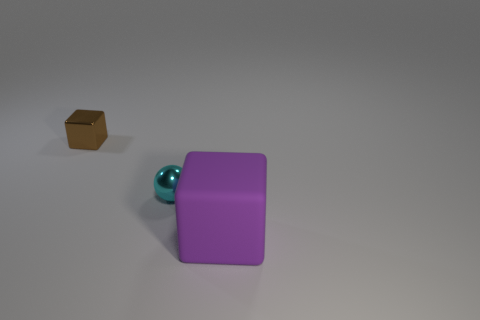Is the large matte thing the same color as the small metal ball?
Offer a terse response. No. There is a thing that is in front of the brown metallic thing and behind the large purple object; what is its size?
Your answer should be very brief. Small. Is there any other thing that has the same material as the purple block?
Give a very brief answer. No. Are the purple thing and the block that is behind the small cyan ball made of the same material?
Your response must be concise. No. Are there fewer big purple cubes that are in front of the big purple cube than cyan shiny things right of the tiny metal sphere?
Provide a succinct answer. No. What material is the tiny object behind the tiny metallic ball?
Your answer should be compact. Metal. There is a thing that is to the right of the small cube and to the left of the purple object; what color is it?
Provide a short and direct response. Cyan. What is the color of the tiny metallic object that is in front of the small brown object?
Your answer should be very brief. Cyan. Is there a blue shiny cube of the same size as the brown block?
Keep it short and to the point. No. There is a brown block that is the same size as the cyan metal sphere; what is it made of?
Give a very brief answer. Metal. 